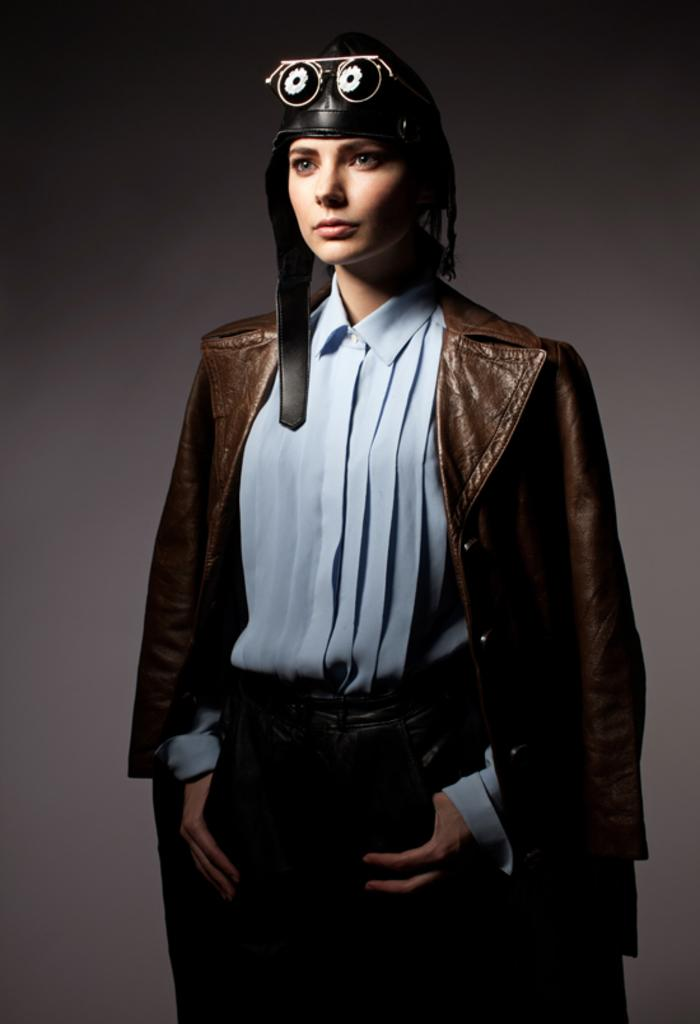Who is the main subject in the foreground of the image? There is a woman in the foreground of the image. What is the woman doing in the image? The woman is standing. What is the woman wearing in the image? The woman is wearing a brown coat. What is the unusual feature on the woman's head in the image? The woman has a helmet-like structure on her head. What is the color of the background in the image? The background of the image is in grey color. Can you tell me how many horses are visible in the image? There are no horses present in the image; it features a woman with a helmet-like structure on her head. What type of metal is used to make the chin of the helmet-like structure in the image? There is no chin or metal mentioned in the image; it only describes a helmet-like structure on the woman's head. 